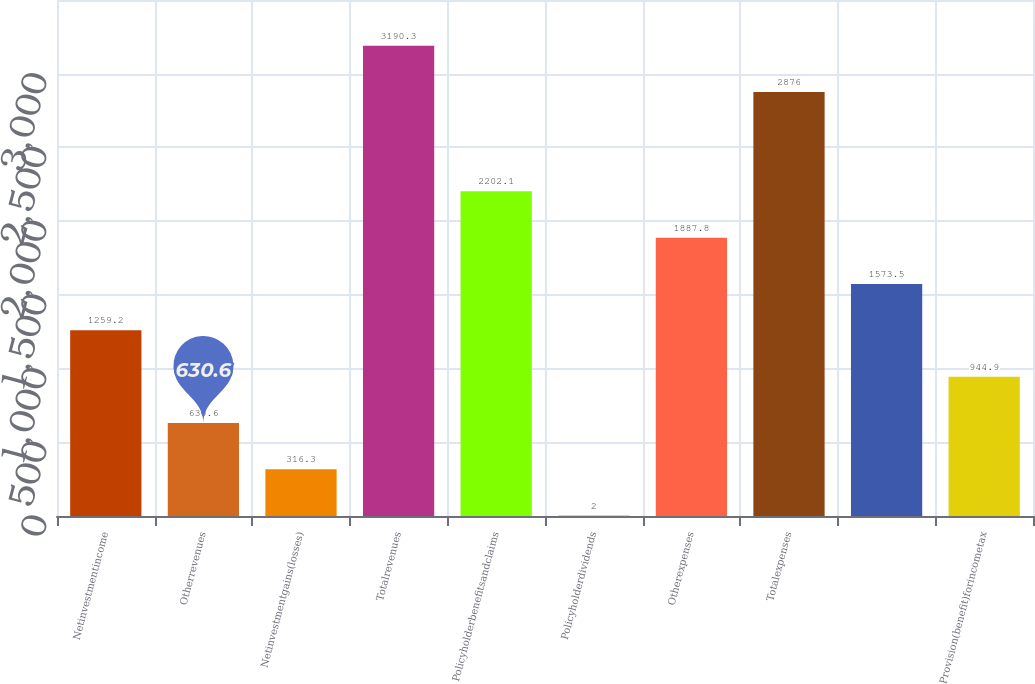<chart> <loc_0><loc_0><loc_500><loc_500><bar_chart><fcel>Netinvestmentincome<fcel>Otherrevenues<fcel>Netinvestmentgains(losses)<fcel>Totalrevenues<fcel>Policyholderbenefitsandclaims<fcel>Policyholderdividends<fcel>Otherexpenses<fcel>Totalexpenses<fcel>Unnamed: 8<fcel>Provision(benefit)forincometax<nl><fcel>1259.2<fcel>630.6<fcel>316.3<fcel>3190.3<fcel>2202.1<fcel>2<fcel>1887.8<fcel>2876<fcel>1573.5<fcel>944.9<nl></chart> 